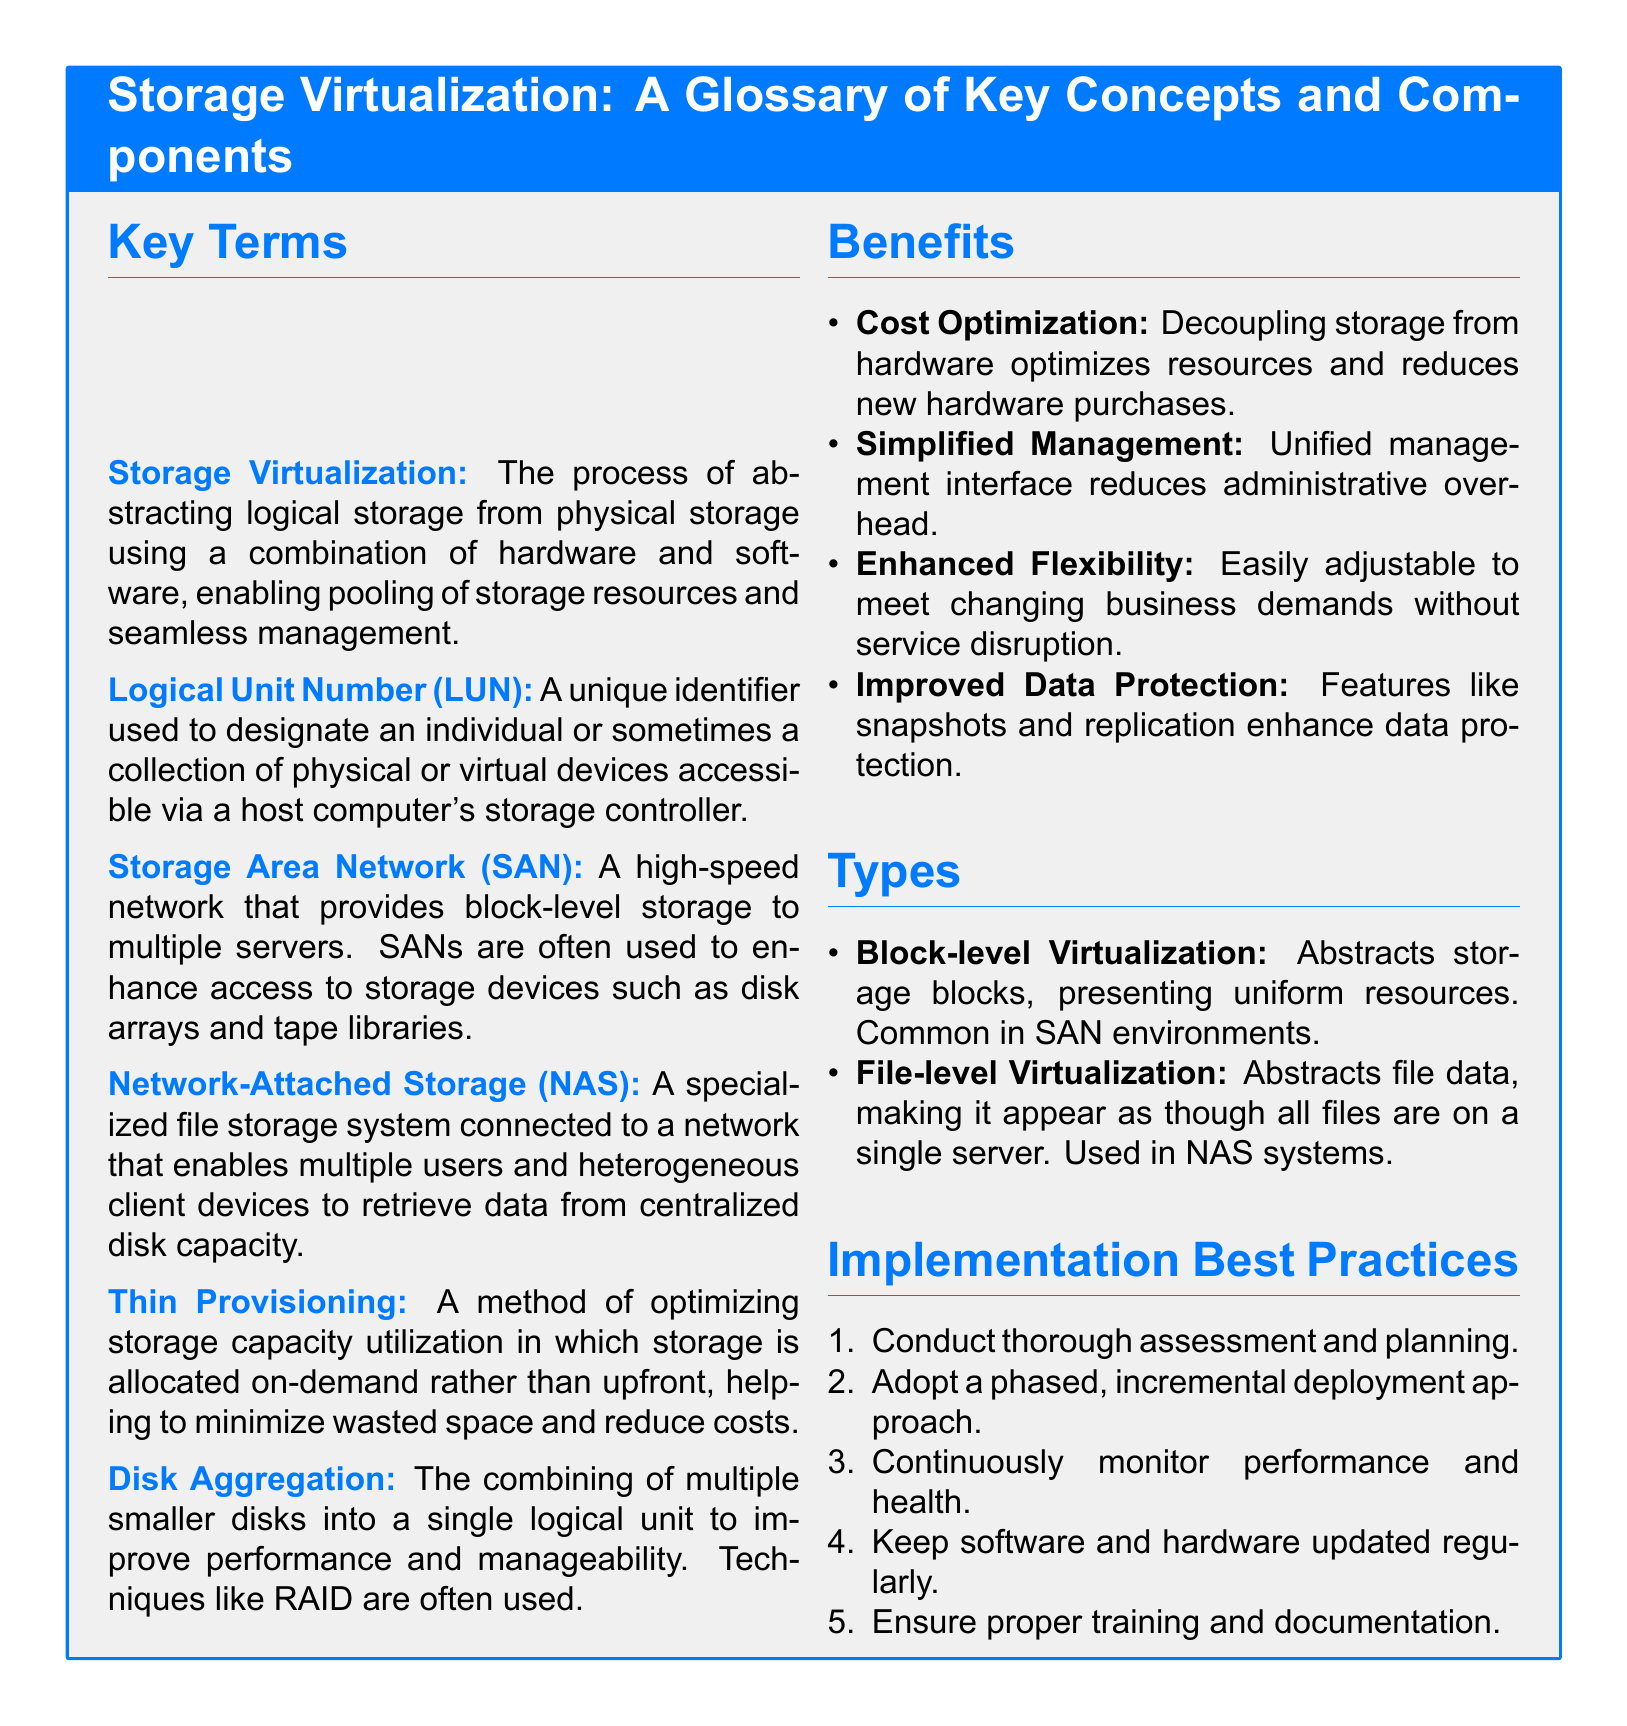What is the main process described in storage virtualization? The main process described in storage virtualization is the abstraction of logical storage from physical storage using hardware and software.
Answer: abstracting logical storage from physical storage What does LUN stand for? LUN stands for Logical Unit Number, which is a unique identifier for storage devices.
Answer: Logical Unit Number What does a SAN primarily provide? A SAN primarily provides block-level storage to multiple servers.
Answer: block-level storage What is the method of optimizing storage capacity called? The method of optimizing storage capacity is called thin provisioning.
Answer: thin provisioning What type of virtualization is common in SAN environments? The type of virtualization common in SAN environments is block-level virtualization.
Answer: block-level virtualization What is the total number of benefits listed in the document? The total number of benefits listed in the document is four.
Answer: four What approach is recommended for deploying storage virtualization? A phased, incremental deployment approach is recommended for deploying storage virtualization.
Answer: phased, incremental deployment What is the first best practice mentioned for implementation? The first best practice mentioned for implementation is conducting thorough assessment and planning.
Answer: conducting thorough assessment and planning What does disk aggregation improve? Disk aggregation improves performance and manageability.
Answer: performance and manageability 